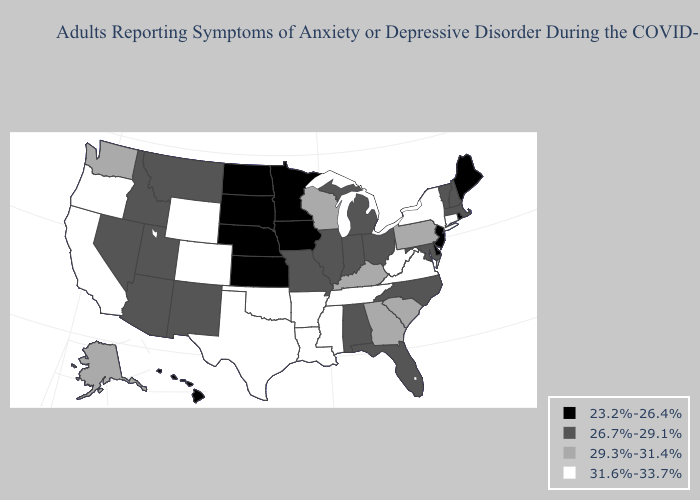Name the states that have a value in the range 23.2%-26.4%?
Be succinct. Delaware, Hawaii, Iowa, Kansas, Maine, Minnesota, Nebraska, New Jersey, North Dakota, Rhode Island, South Dakota. What is the lowest value in states that border South Dakota?
Short answer required. 23.2%-26.4%. Among the states that border Washington , does Idaho have the highest value?
Answer briefly. No. What is the value of Texas?
Short answer required. 31.6%-33.7%. Which states have the highest value in the USA?
Quick response, please. Arkansas, California, Colorado, Connecticut, Louisiana, Mississippi, New York, Oklahoma, Oregon, Tennessee, Texas, Virginia, West Virginia, Wyoming. What is the highest value in states that border New York?
Be succinct. 31.6%-33.7%. What is the highest value in the South ?
Short answer required. 31.6%-33.7%. Is the legend a continuous bar?
Keep it brief. No. Is the legend a continuous bar?
Answer briefly. No. Name the states that have a value in the range 26.7%-29.1%?
Concise answer only. Alabama, Arizona, Florida, Idaho, Illinois, Indiana, Maryland, Massachusetts, Michigan, Missouri, Montana, Nevada, New Hampshire, New Mexico, North Carolina, Ohio, Utah, Vermont. Among the states that border Rhode Island , which have the highest value?
Give a very brief answer. Connecticut. Is the legend a continuous bar?
Short answer required. No. Does Indiana have the same value as New Hampshire?
Quick response, please. Yes. What is the highest value in states that border Maine?
Write a very short answer. 26.7%-29.1%. 